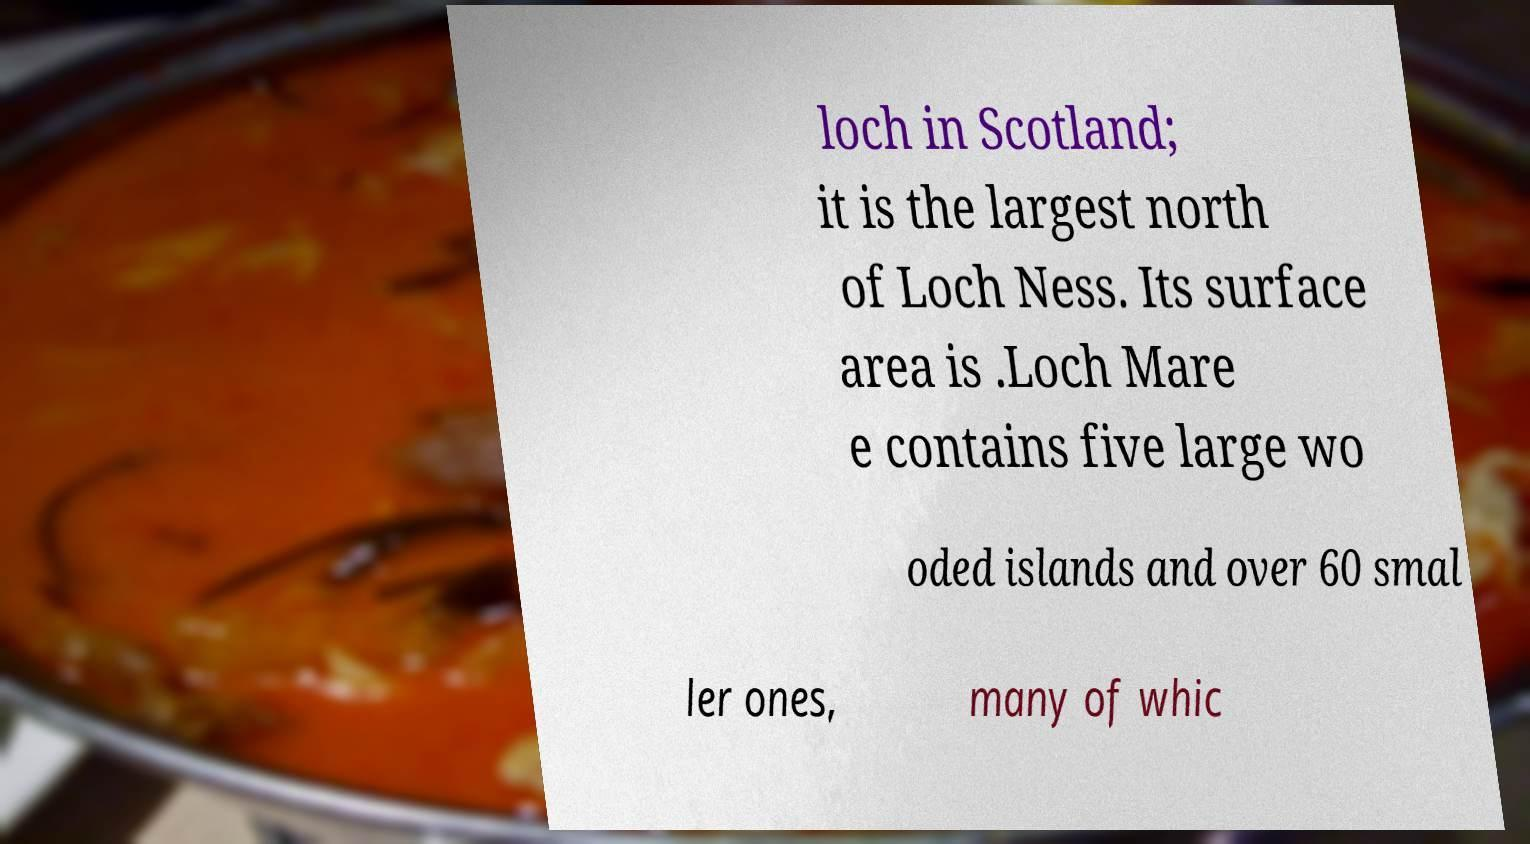Could you extract and type out the text from this image? loch in Scotland; it is the largest north of Loch Ness. Its surface area is .Loch Mare e contains five large wo oded islands and over 60 smal ler ones, many of whic 